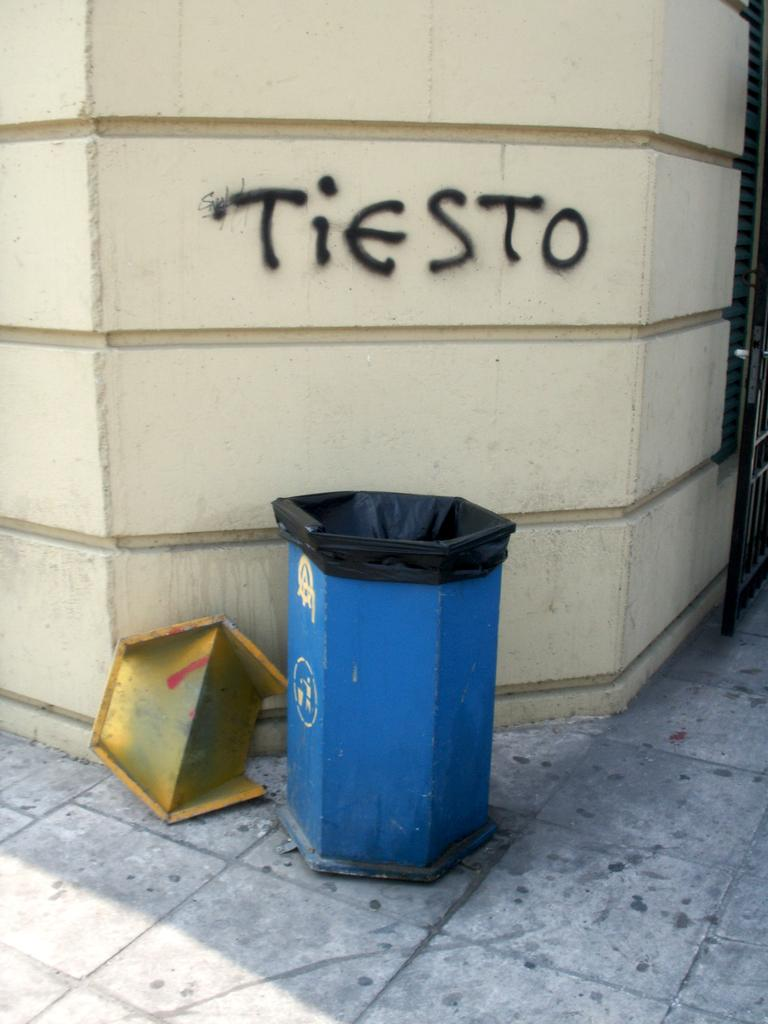<image>
Render a clear and concise summary of the photo. Someone has spray painted Tiesto on a wall in black paint. 